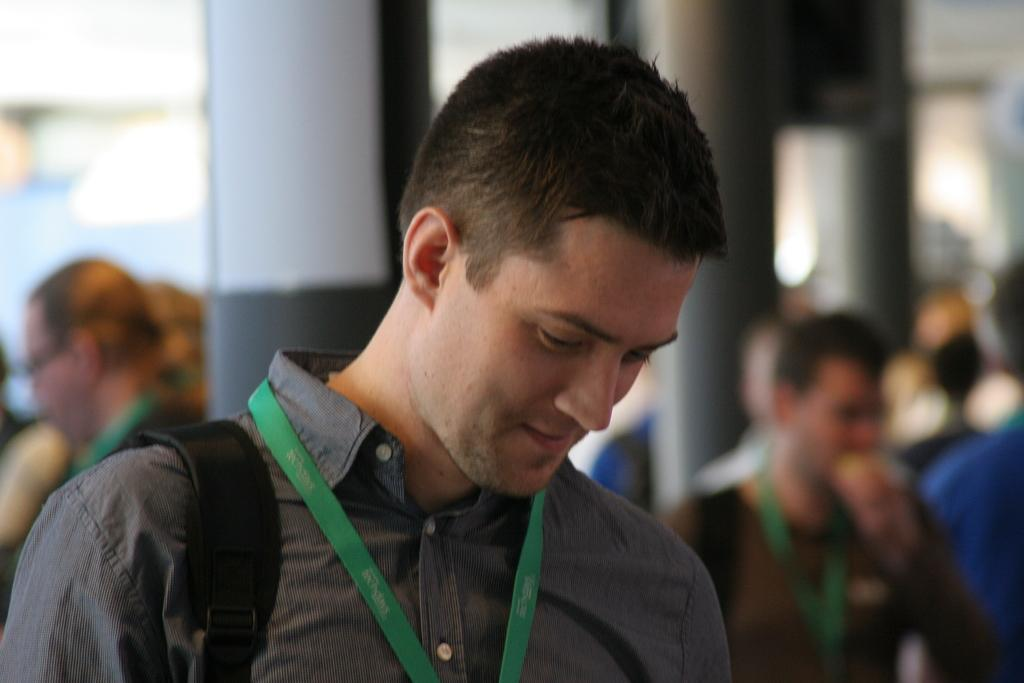Who is present in the image? There is a man in the image. What is the man's facial expression? The man is smiling. What can be seen in the background of the image? There is a group of people and objects visible in the background of the image. How would you describe the background of the image? The background of the image is blurry. What type of mint is growing in the vase in the image? There is no mint or vase present in the image. 